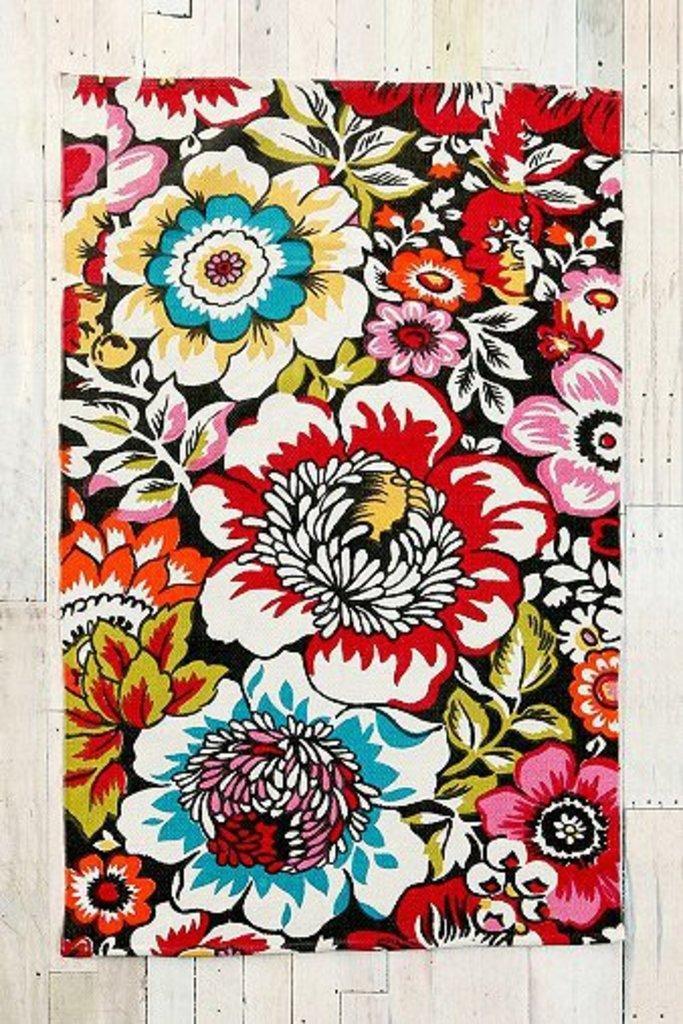Could you give a brief overview of what you see in this image? In the image in the center we can see one colorful cloth on the wooden wall. 